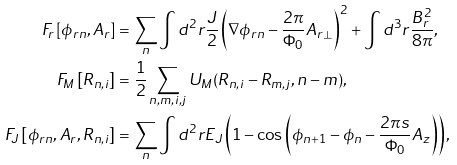Convert formula to latex. <formula><loc_0><loc_0><loc_500><loc_500>F _ { r } \left [ \phi _ { r n } , A _ { r } \right ] & = \sum _ { n } \int d ^ { 2 } r \frac { J } { 2 } \left ( \nabla \phi _ { r n } - \frac { 2 \pi } { \Phi _ { 0 } } A _ { r \perp } \right ) ^ { 2 } + \int d ^ { 3 } r \frac { B _ { r } ^ { 2 } } { 8 \pi } , \\ F _ { M } \left [ R _ { n , i } \right ] & = \frac { 1 } { 2 } \sum _ { n , m , i , j } U _ { M } ( R _ { n , i } - R _ { m , j } , n - m ) , \\ F _ { J } \left [ \phi _ { r n } , A _ { r } , R _ { n , i } \right ] & = \sum _ { n } \int d ^ { 2 } r E _ { J } \left ( 1 - \cos \left ( \phi _ { n + 1 } - \phi _ { n } - \frac { 2 \pi s } { \Phi _ { 0 } } A _ { z } \right ) \right ) ,</formula> 